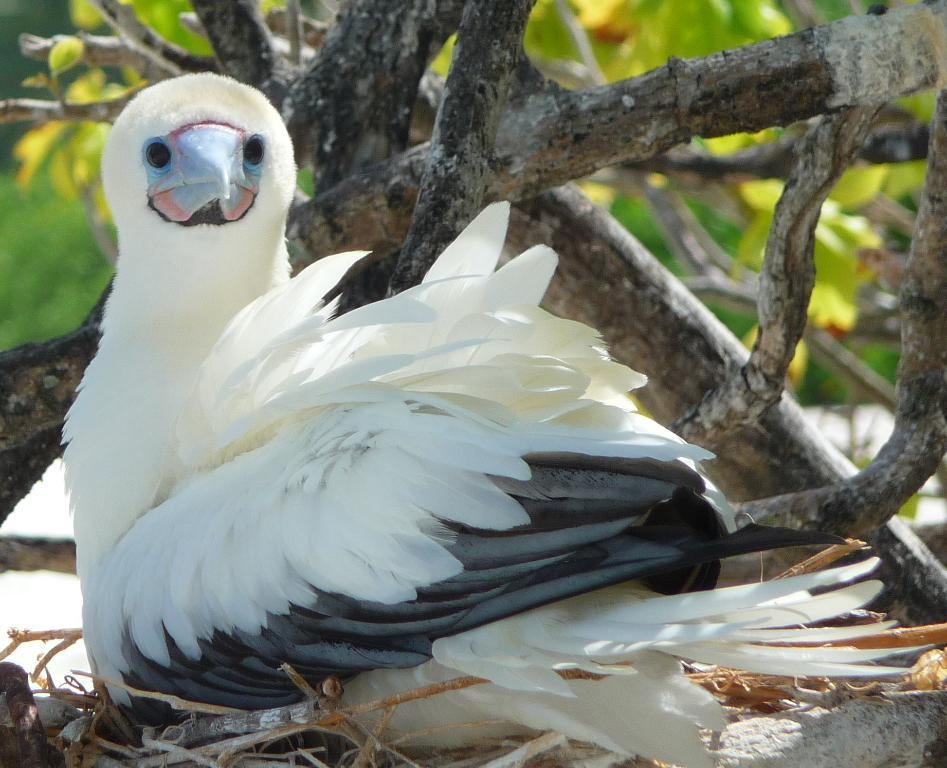What is the person in the image holding? The person in the image is holding a camera. What is the person using to support the camera? There is a tripod in the image that the person is using to support the camera. What can be seen in the background of the image? There is a building in the background of the image. How many giants are visible in the image? There are no giants present in the image. What type of knee brace is the person wearing in the image? There is no mention of a knee brace or any medical equipment in the image. 